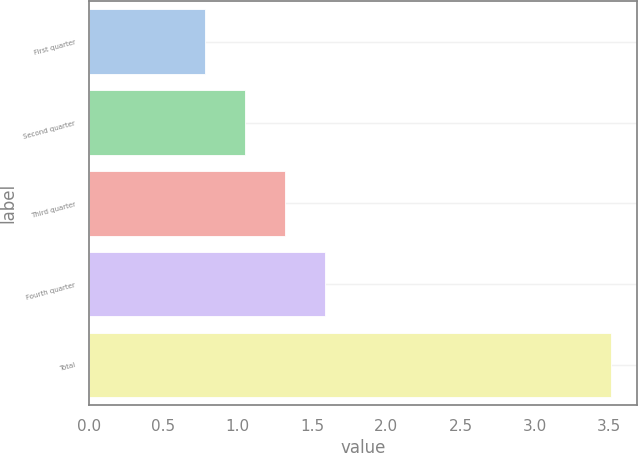<chart> <loc_0><loc_0><loc_500><loc_500><bar_chart><fcel>First quarter<fcel>Second quarter<fcel>Third quarter<fcel>Fourth quarter<fcel>Total<nl><fcel>0.78<fcel>1.05<fcel>1.32<fcel>1.59<fcel>3.51<nl></chart> 